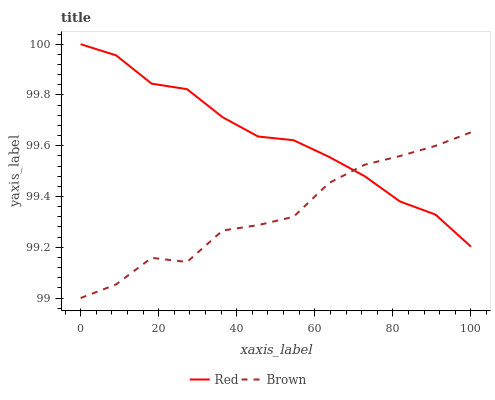Does Brown have the minimum area under the curve?
Answer yes or no. Yes. Does Red have the maximum area under the curve?
Answer yes or no. Yes. Does Red have the minimum area under the curve?
Answer yes or no. No. Is Red the smoothest?
Answer yes or no. Yes. Is Brown the roughest?
Answer yes or no. Yes. Is Red the roughest?
Answer yes or no. No. Does Brown have the lowest value?
Answer yes or no. Yes. Does Red have the lowest value?
Answer yes or no. No. Does Red have the highest value?
Answer yes or no. Yes. Does Brown intersect Red?
Answer yes or no. Yes. Is Brown less than Red?
Answer yes or no. No. Is Brown greater than Red?
Answer yes or no. No. 